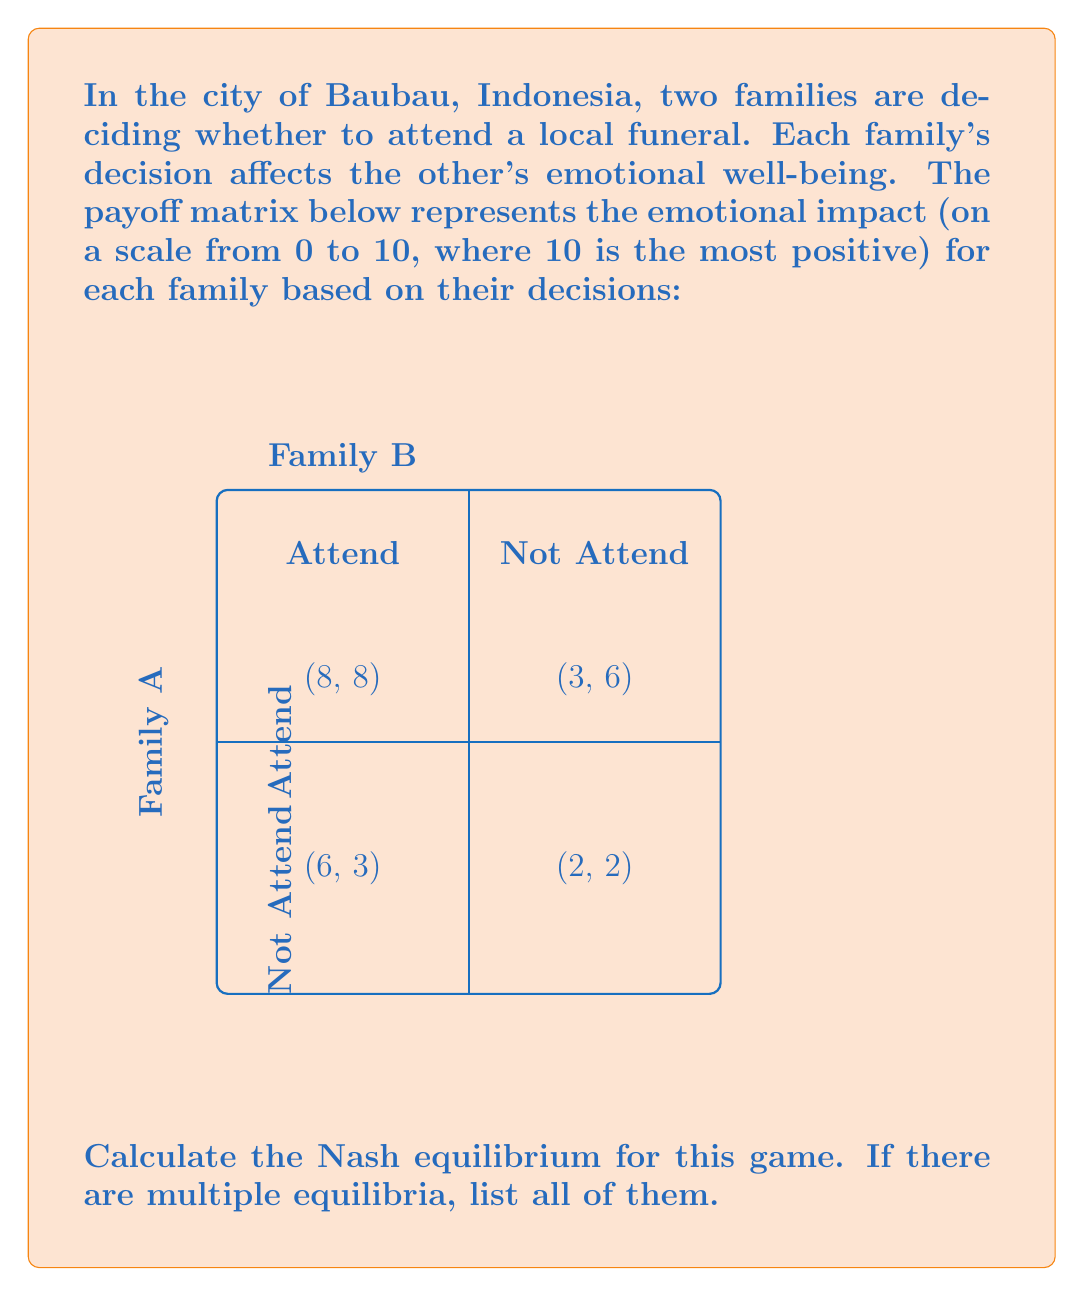Give your solution to this math problem. To find the Nash equilibrium, we need to determine the best response for each family given the other family's strategy.

Step 1: Analyze Family A's strategies
- If Family B attends:
  Family A's payoff for attending: 8
  Family A's payoff for not attending: 6
  Best response: Attend
- If Family B does not attend:
  Family A's payoff for attending: 3
  Family A's payoff for not attending: 2
  Best response: Attend

Step 2: Analyze Family B's strategies
- If Family A attends:
  Family B's payoff for attending: 8
  Family B's payoff for not attending: 3
  Best response: Attend
- If Family A does not attend:
  Family B's payoff for attending: 6
  Family B's payoff for not attending: 2
  Best response: Attend

Step 3: Identify Nash equilibria
A Nash equilibrium occurs when both families are playing their best responses to each other's strategies. From our analysis:

- (Attend, Attend) is a Nash equilibrium because:
  * Family A's best response to Family B attending is to attend
  * Family B's best response to Family A attending is to attend

- There are no other Nash equilibria because for all other strategy combinations, at least one family has an incentive to change their strategy.

Therefore, the unique Nash equilibrium for this game is (Attend, Attend).
Answer: (Attend, Attend) 